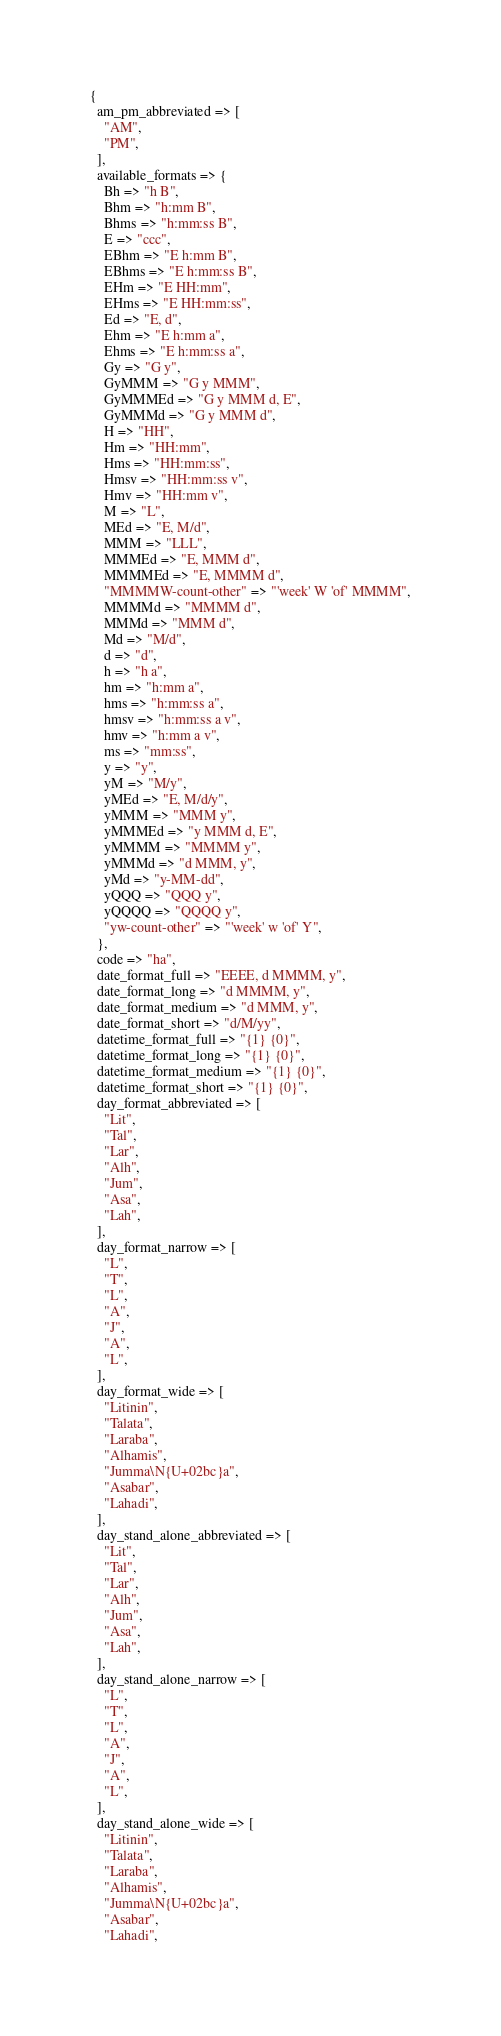Convert code to text. <code><loc_0><loc_0><loc_500><loc_500><_Perl_>{
  am_pm_abbreviated => [
    "AM",
    "PM",
  ],
  available_formats => {
    Bh => "h B",
    Bhm => "h:mm B",
    Bhms => "h:mm:ss B",
    E => "ccc",
    EBhm => "E h:mm B",
    EBhms => "E h:mm:ss B",
    EHm => "E HH:mm",
    EHms => "E HH:mm:ss",
    Ed => "E, d",
    Ehm => "E h:mm a",
    Ehms => "E h:mm:ss a",
    Gy => "G y",
    GyMMM => "G y MMM",
    GyMMMEd => "G y MMM d, E",
    GyMMMd => "G y MMM d",
    H => "HH",
    Hm => "HH:mm",
    Hms => "HH:mm:ss",
    Hmsv => "HH:mm:ss v",
    Hmv => "HH:mm v",
    M => "L",
    MEd => "E, M/d",
    MMM => "LLL",
    MMMEd => "E, MMM d",
    MMMMEd => "E, MMMM d",
    "MMMMW-count-other" => "'week' W 'of' MMMM",
    MMMMd => "MMMM d",
    MMMd => "MMM d",
    Md => "M/d",
    d => "d",
    h => "h a",
    hm => "h:mm a",
    hms => "h:mm:ss a",
    hmsv => "h:mm:ss a v",
    hmv => "h:mm a v",
    ms => "mm:ss",
    y => "y",
    yM => "M/y",
    yMEd => "E, M/d/y",
    yMMM => "MMM y",
    yMMMEd => "y MMM d, E",
    yMMMM => "MMMM y",
    yMMMd => "d MMM, y",
    yMd => "y-MM-dd",
    yQQQ => "QQQ y",
    yQQQQ => "QQQQ y",
    "yw-count-other" => "'week' w 'of' Y",
  },
  code => "ha",
  date_format_full => "EEEE, d MMMM, y",
  date_format_long => "d MMMM, y",
  date_format_medium => "d MMM, y",
  date_format_short => "d/M/yy",
  datetime_format_full => "{1} {0}",
  datetime_format_long => "{1} {0}",
  datetime_format_medium => "{1} {0}",
  datetime_format_short => "{1} {0}",
  day_format_abbreviated => [
    "Lit",
    "Tal",
    "Lar",
    "Alh",
    "Jum",
    "Asa",
    "Lah",
  ],
  day_format_narrow => [
    "L",
    "T",
    "L",
    "A",
    "J",
    "A",
    "L",
  ],
  day_format_wide => [
    "Litinin",
    "Talata",
    "Laraba",
    "Alhamis",
    "Jumma\N{U+02bc}a",
    "Asabar",
    "Lahadi",
  ],
  day_stand_alone_abbreviated => [
    "Lit",
    "Tal",
    "Lar",
    "Alh",
    "Jum",
    "Asa",
    "Lah",
  ],
  day_stand_alone_narrow => [
    "L",
    "T",
    "L",
    "A",
    "J",
    "A",
    "L",
  ],
  day_stand_alone_wide => [
    "Litinin",
    "Talata",
    "Laraba",
    "Alhamis",
    "Jumma\N{U+02bc}a",
    "Asabar",
    "Lahadi",</code> 